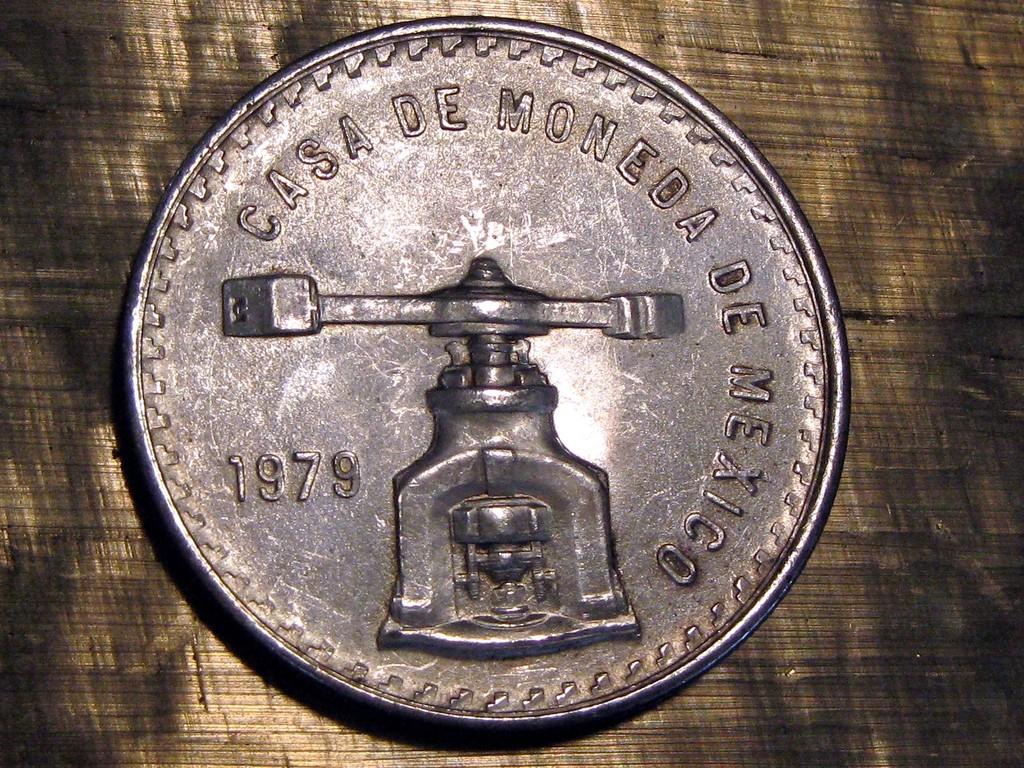What year is this coin minted?
Offer a very short reply. 1979. What county was this coin minted in?
Your answer should be very brief. Mexico. 